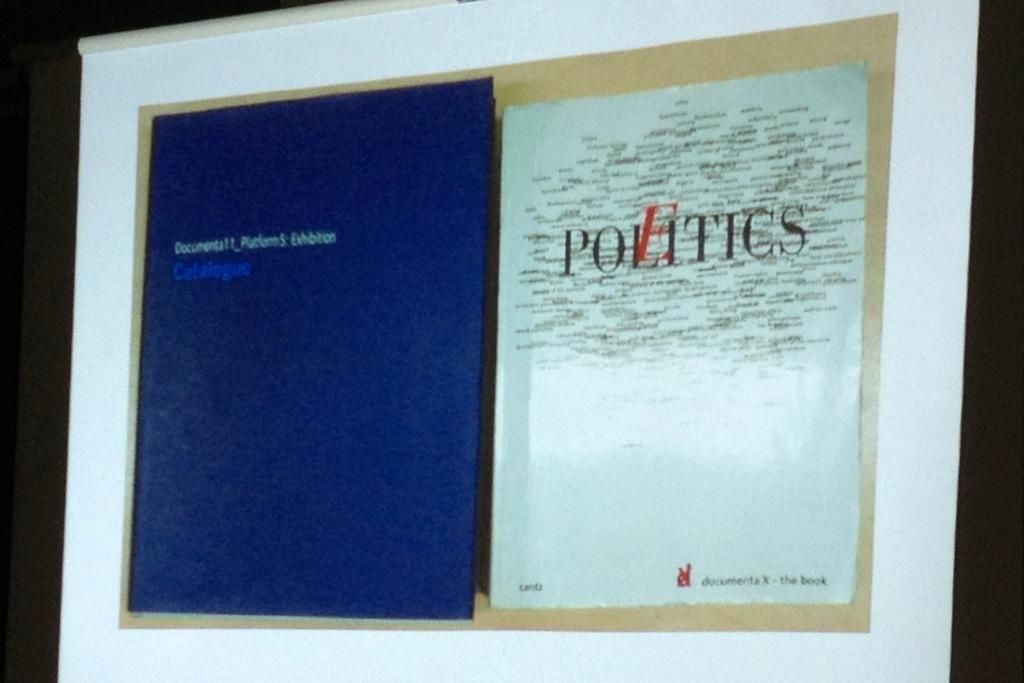<image>
Provide a brief description of the given image. Screen showing a book with the word "Politics" on it. 